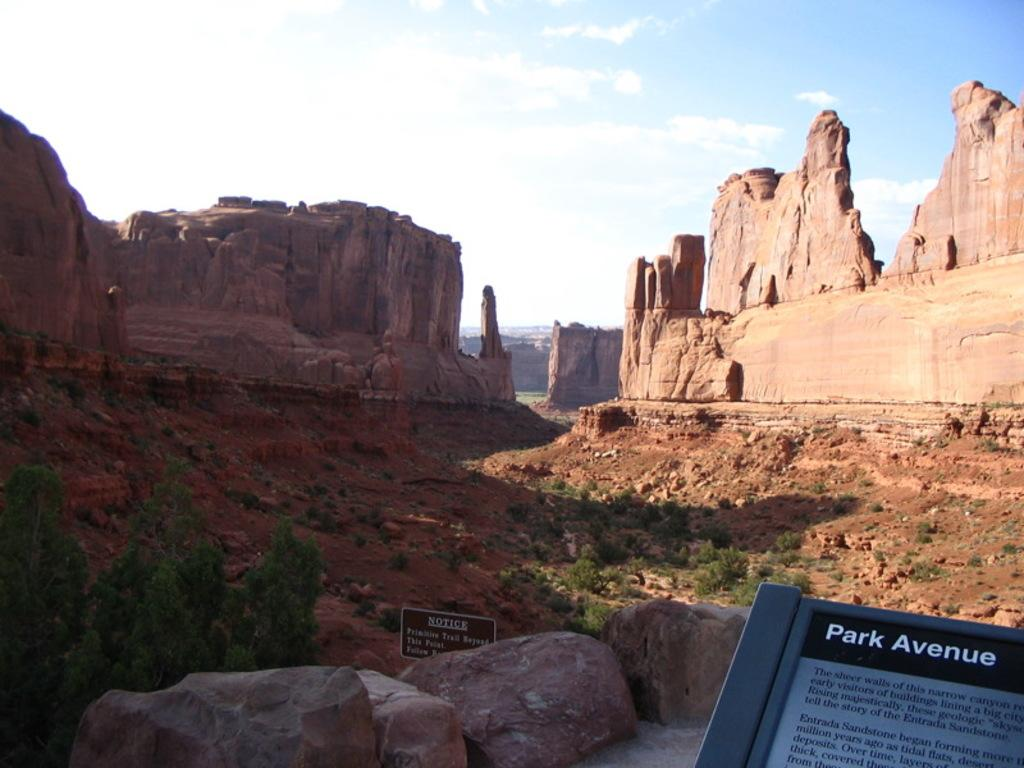What type of natural formation can be seen in the image? There are rock mountains in the image. What other natural elements are present in the image? There are plants and trees in the image. What man-made objects can be seen in the image? There are sign boards in the image. What type of terrain is visible in the image? There are stones and mud in the image. What is visible in the sky in the image? There are clouds in the sky in the image. What design or idea can be seen on the drain in the image? There is no drain present in the image; it features rock mountains, plants and trees, sign boards, stones, mud, and clouds. 